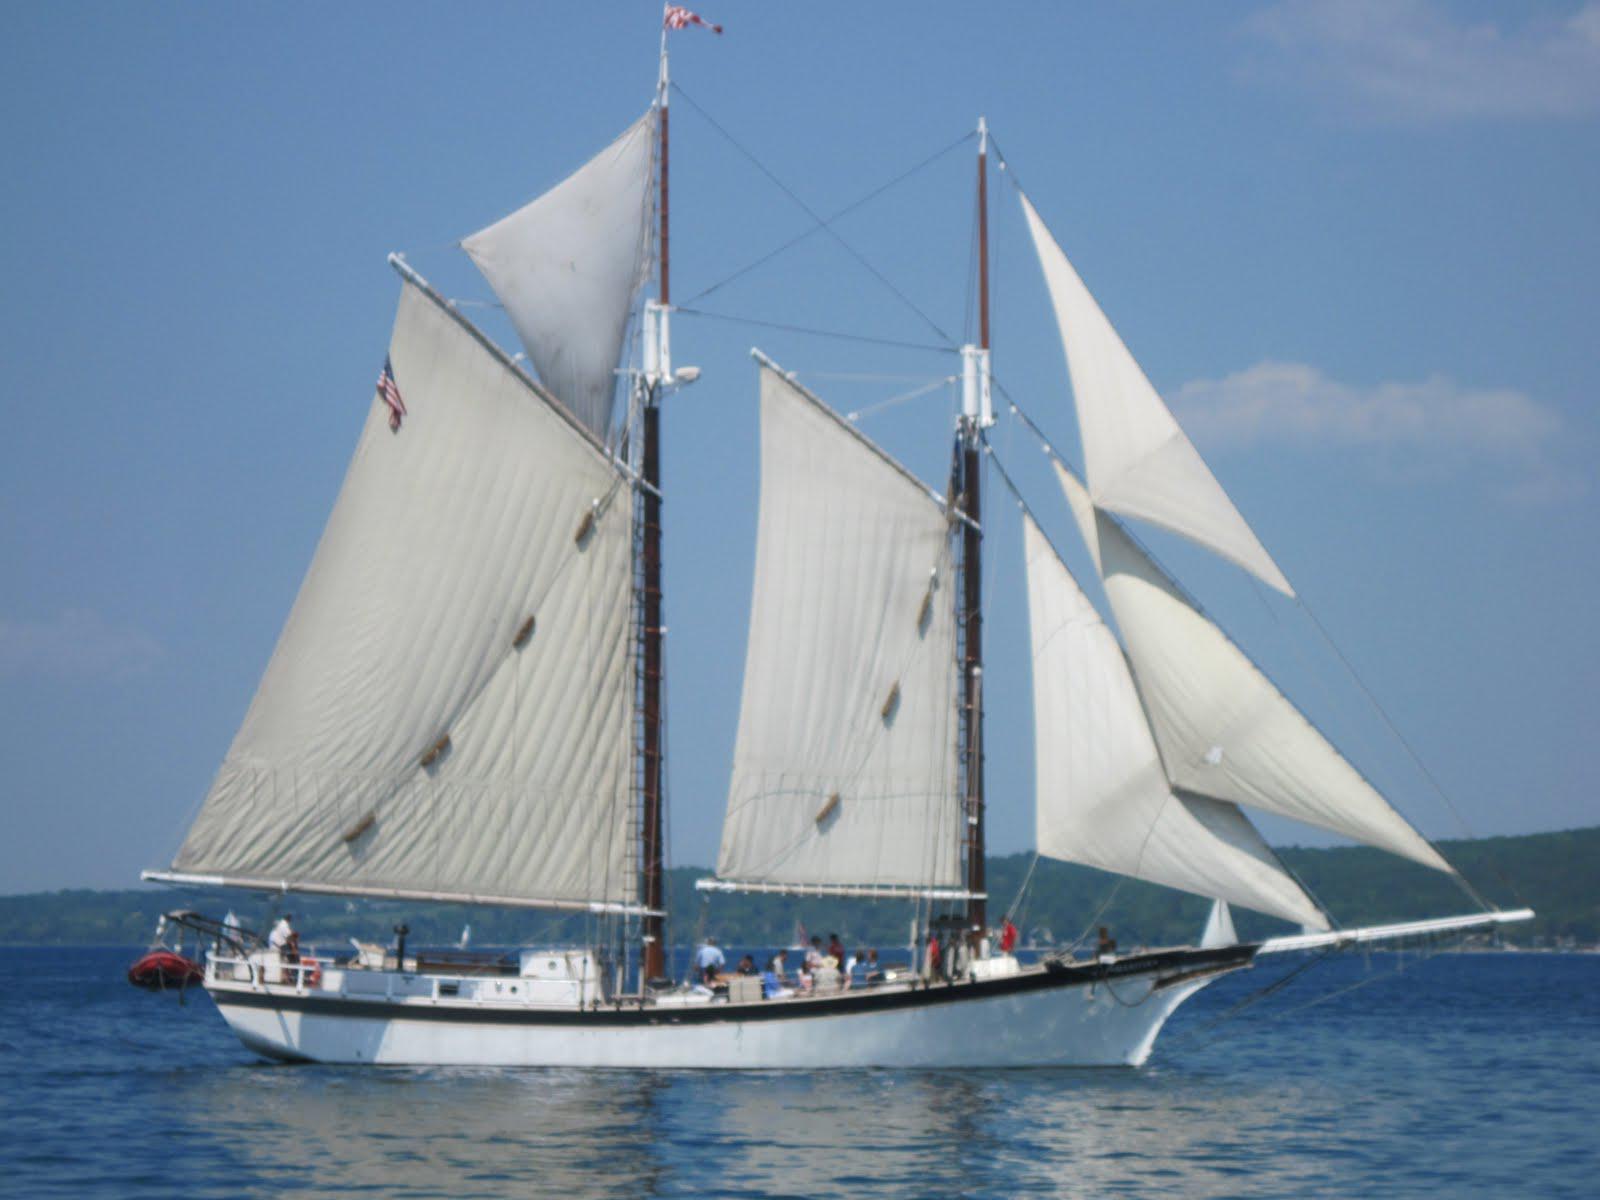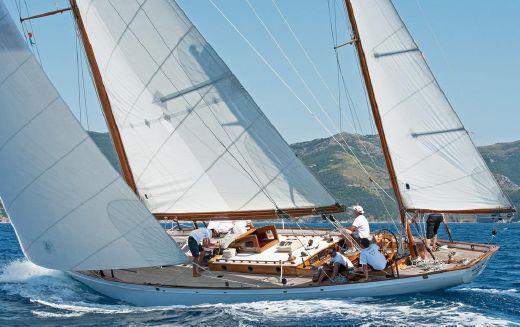The first image is the image on the left, the second image is the image on the right. Examine the images to the left and right. Is the description "In one image, a moving sailboat's three triangular sails are angled with their peaks toward the upper left." accurate? Answer yes or no. Yes. 